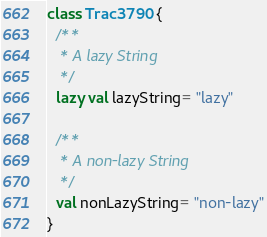<code> <loc_0><loc_0><loc_500><loc_500><_Scala_>class Trac3790 {
  /**
   * A lazy String
   */
  lazy val lazyString= "lazy"

  /**
   * A non-lazy String
   */
  val nonLazyString= "non-lazy"
}
</code> 